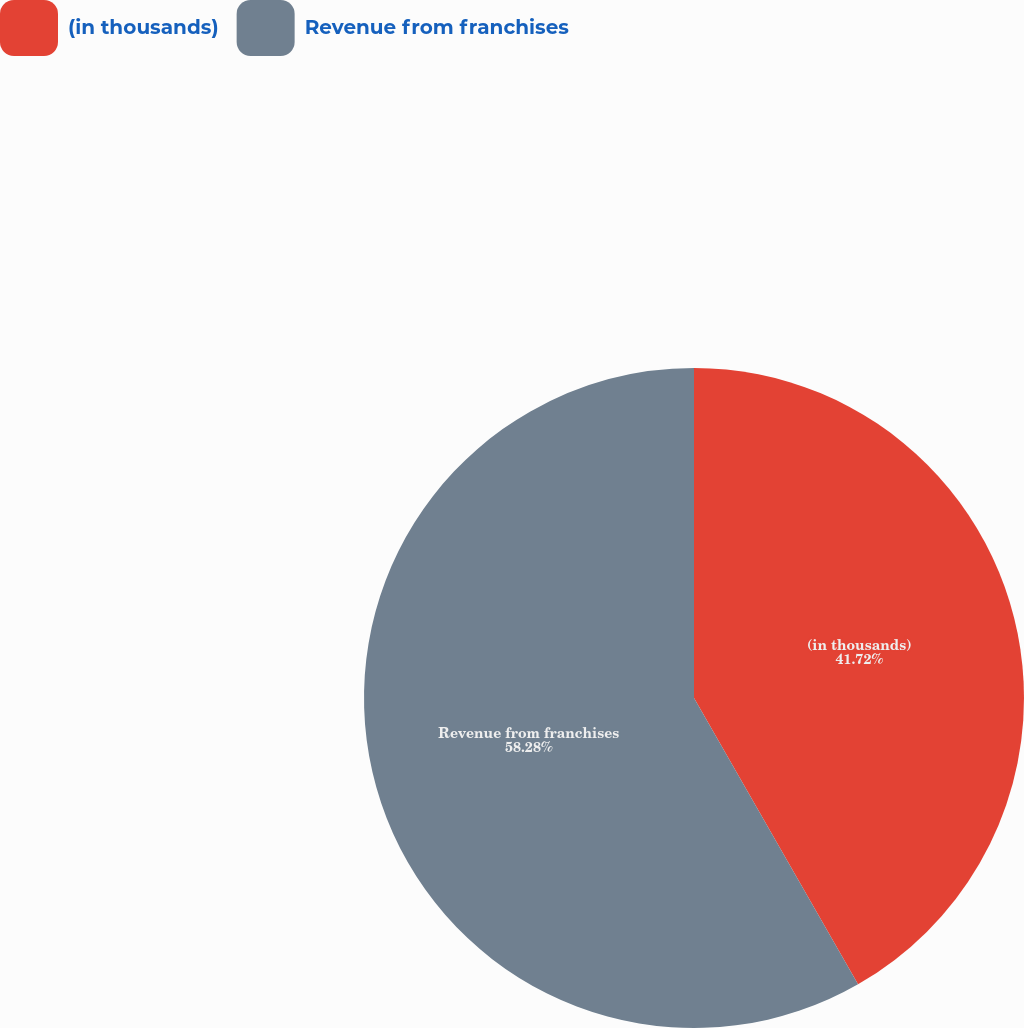Convert chart to OTSL. <chart><loc_0><loc_0><loc_500><loc_500><pie_chart><fcel>(in thousands)<fcel>Revenue from franchises<nl><fcel>41.72%<fcel>58.28%<nl></chart> 